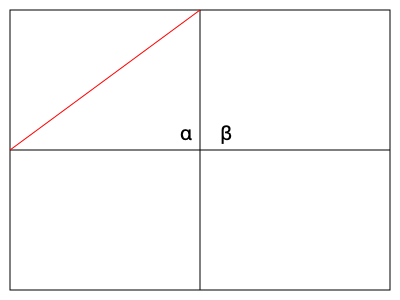On the Bombers' home field, the diagonal line from the corner to the 50-yard line forms two angles with the sideline and midfield line. If angle α is 30°, what is the measure of angle β? Let's approach this step-by-step:

1) First, recall that the football field is rectangular. This means that the corner where the sideline meets the end zone forms a 90° angle.

2) The diagonal line from the corner to the 50-yard line creates two angles with the sideline (α) and the midfield line (β).

3) Since these three angles (α, β, and the 90° corner) form a complete angle at a point, we know that their sum must be 180°.

4) We can express this as an equation:
   
   $α + β + 90° = 180°$

5) We're given that $α = 30°$. Let's substitute this into our equation:
   
   $30° + β + 90° = 180°$

6) Now we can solve for β:
   
   $β + 120° = 180°$
   $β = 180° - 120°$
   $β = 60°$

Therefore, the measure of angle β is 60°.
Answer: 60° 